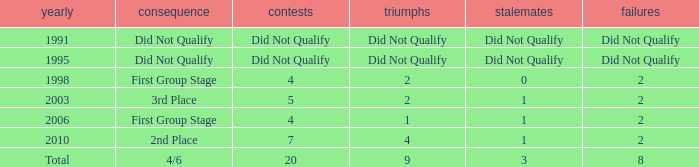What was the result for the team with 3 draws? 4/6. 